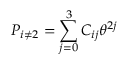Convert formula to latex. <formula><loc_0><loc_0><loc_500><loc_500>P _ { i \neq 2 } = \sum _ { j = 0 } ^ { 3 } C _ { i j } \theta ^ { 2 j }</formula> 